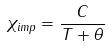<formula> <loc_0><loc_0><loc_500><loc_500>\chi _ { i m p } = \frac { C } { T + \theta }</formula> 